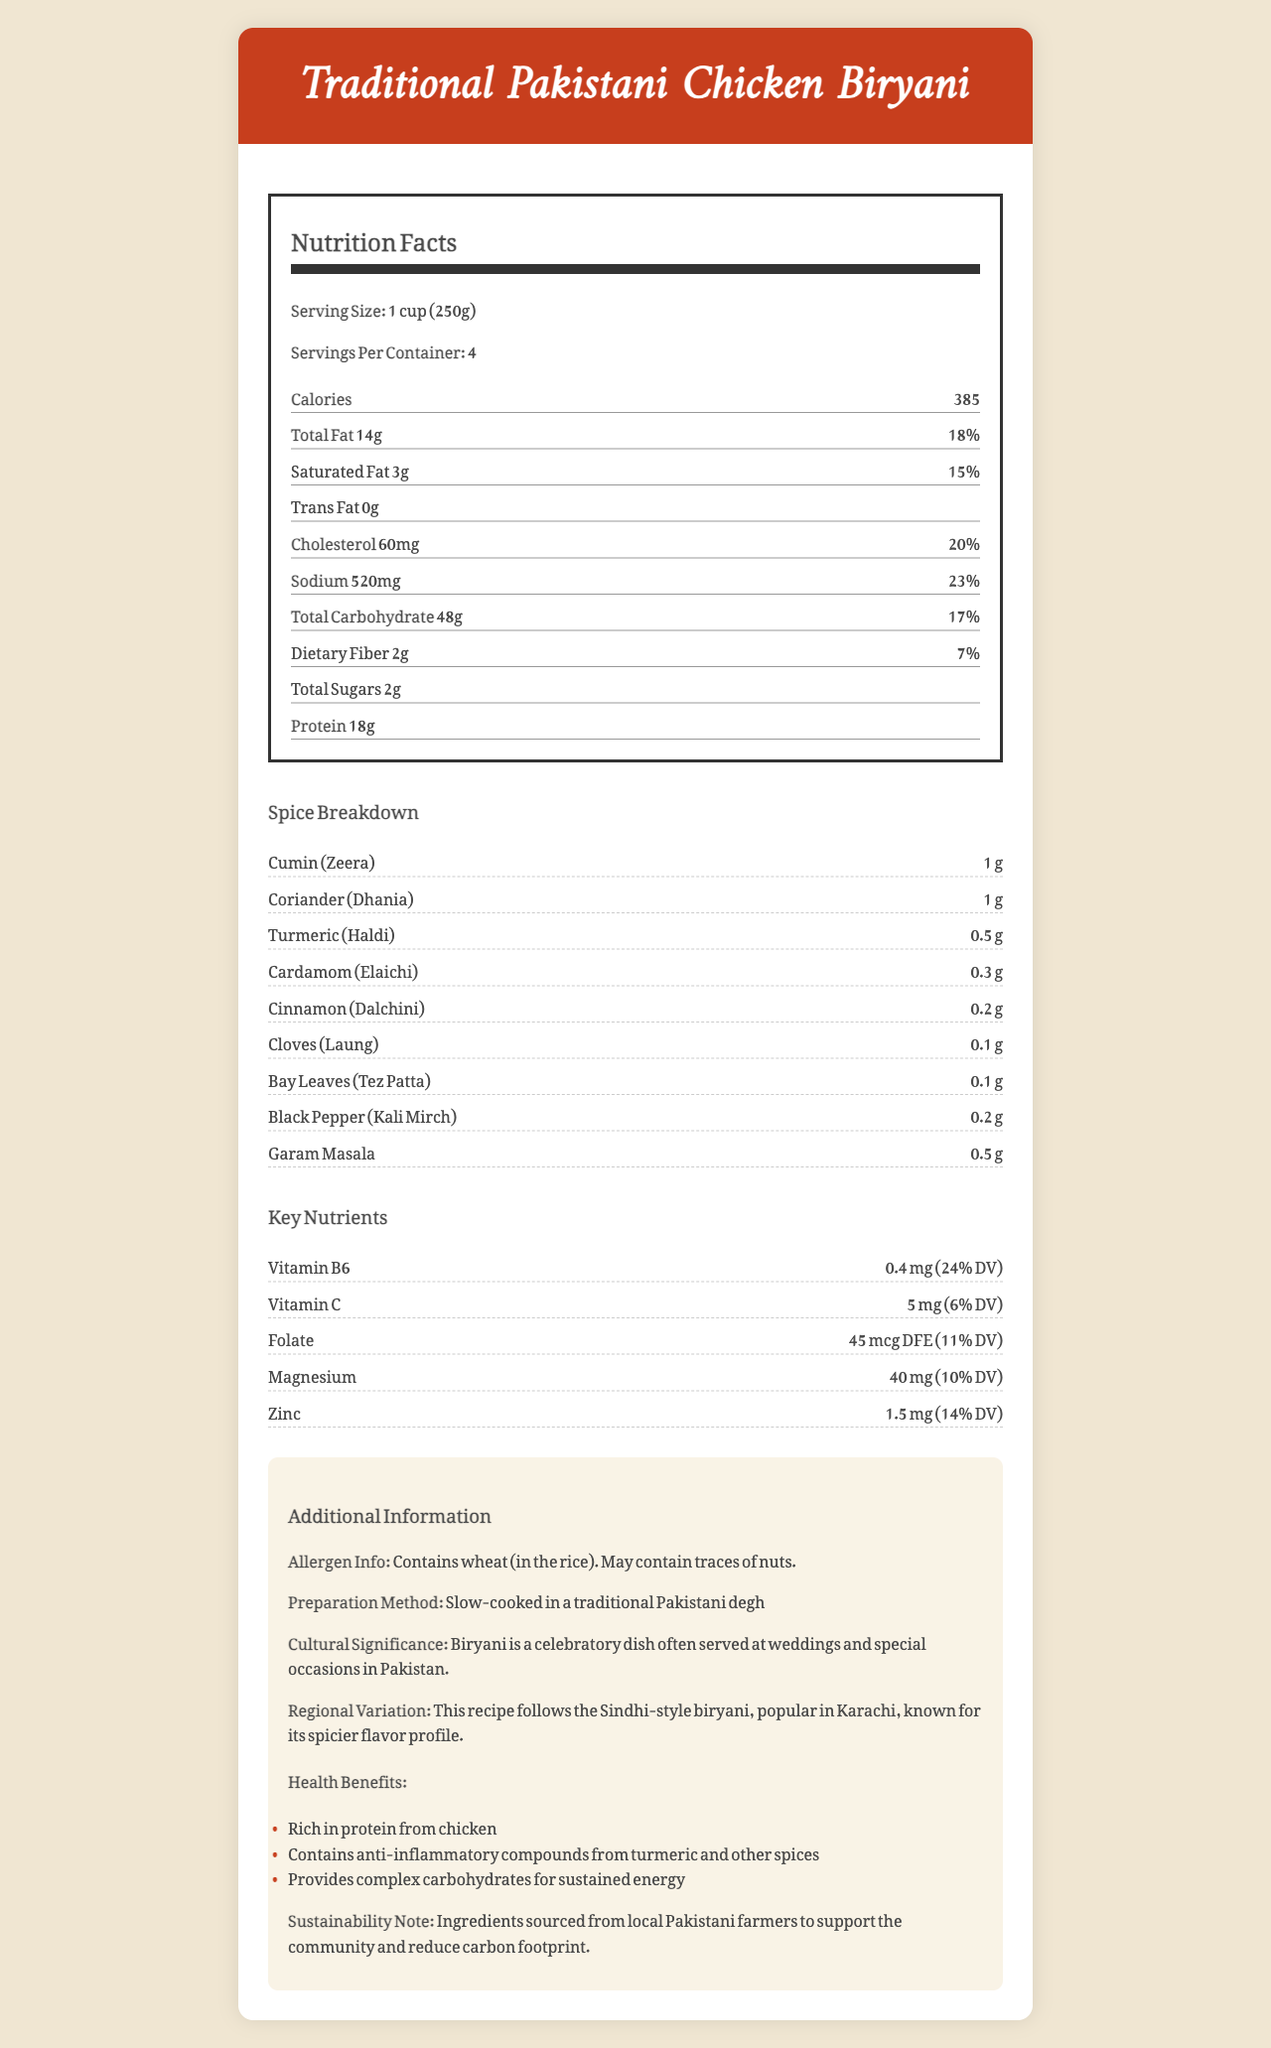How many calories are in one serving of Traditional Pakistani Chicken Biryani? The document states that one serving (1 cup or 250g) of Traditional Pakistani Chicken Biryani contains 385 calories.
Answer: 385 calories What is the serving size mentioned in the document? The document specifies that the serving size for the Traditional Pakistani Chicken Biryani is 1 cup, which is equivalent to 250 grams.
Answer: 1 cup (250g) How much saturated fat does one serving contain, and what percentage of the daily value does this represent? According to the document, one serving contains 3 grams of saturated fat, which is 15% of the daily value.
Answer: 3g, 15% What are the two key nutrients with the highest daily value percentage in the biryani? Vitamin B6 has a daily value of 24%, and Vitamin C has a daily value of 6%, which are the two highest percentages among the key nutrients listed.
Answer: Vitamin B6 and Vitamin C True or False: The biryani contains trans fat. The document states that the amount of trans fat in the biryani is 0 grams.
Answer: False What is the amount of sodium in one-serving of biryani? The document mentions that there are 520 milligrams of sodium in one serving of the biryani.
Answer: 520 mg Which type of biryani is described in the document? A. Hyderabadi Biryani B. Sindhi Biryani C. Bombay Biryani D. Lucknowi Biryani The document clearly states that this recipe follows the Sindhi-style biryani popular in Karachi, known for its spicier flavor profile.
Answer: B. Sindhi Biryani Which spice is used in the largest quantity in the chicken biryani? The document lists 1 gram of Cumin (Zeera) as the largest quantity among the spices used.
Answer: Cumin (Zeera) What is the total carbohydrate content in one serving? The document specifies that the total carbohydrate content in one serving of the biryani is 48 grams.
Answer: 48g Which of the following are health benefits mentioned in the document? A. Rich in Vitamin A B. Contains anti-inflammatory compounds C. High in saturated fat D. Low in sodium The document mentions anti-inflammatory compounds from turmeric and other spices as one of the health benefits.
Answer: B. Contains anti-inflammatory compounds Summarize the nutritional profile of Traditional Pakistani Chicken Biryani. The dish has a balanced nutritional profile with a focus on protein and beneficial spices while also providing a good amount of vitamins and minerals.
Answer: The Traditional Pakistani Chicken Biryani is a flavorful dish with a serving size of 1 cup (250g). Each serving contains 385 calories, 14g of total fat including 3g of saturated fat, 520mg of sodium, 48g of carbohydrates with 2g of fiber and 2g of sugars, and 18g of protein. It also contains various vitamins and minerals like Vitamin B6, Vitamin C, folate, magnesium, and zinc. The dish is rich in protein and complex carbohydrates and contains several beneficial spices. What is the daily value percentage of calcium provided by one serving of biryani? The document indicates that one serving of biryani provides 2% of the daily value for calcium.
Answer: 2% Is there any information about the sustainability of the biryani ingredients? The document notes that the ingredients are sourced from local Pakistani farmers to support the community and reduce the carbon footprint.
Answer: Yes What is the total fat content per serving and its corresponding percentage of the daily value? The document reports that one serving contains 14 grams of total fat, which corresponds to 18% of the daily value.
Answer: 14g, 18% How much black pepper (Kali Mirch) is used in the spice breakdown? The document lists 0.2 grams of black pepper in the spice breakdown.
Answer: 0.2g What can be concluded about the cholesterol content? The document mentions that one serving of biryani contains 60 milligrams of cholesterol, which is 20% of the daily value.
Answer: 60 mg, 20% Who is the intended demographic for this document? The document does not provide explicit information about its intended demographic audience.
Answer: Cannot be determined 